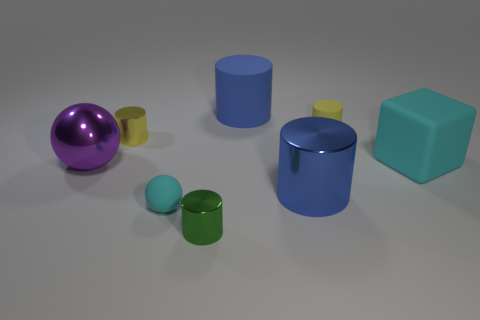Add 2 big metal cylinders. How many objects exist? 10 Subtract all green cylinders. How many cylinders are left? 4 Subtract all red cubes. How many yellow cylinders are left? 2 Subtract 1 cylinders. How many cylinders are left? 4 Subtract all blue cylinders. How many cylinders are left? 3 Subtract all yellow cylinders. Subtract all yellow spheres. How many cylinders are left? 3 Subtract all spheres. How many objects are left? 6 Subtract 0 red cylinders. How many objects are left? 8 Subtract all green metal cylinders. Subtract all small green cylinders. How many objects are left? 6 Add 2 blue objects. How many blue objects are left? 4 